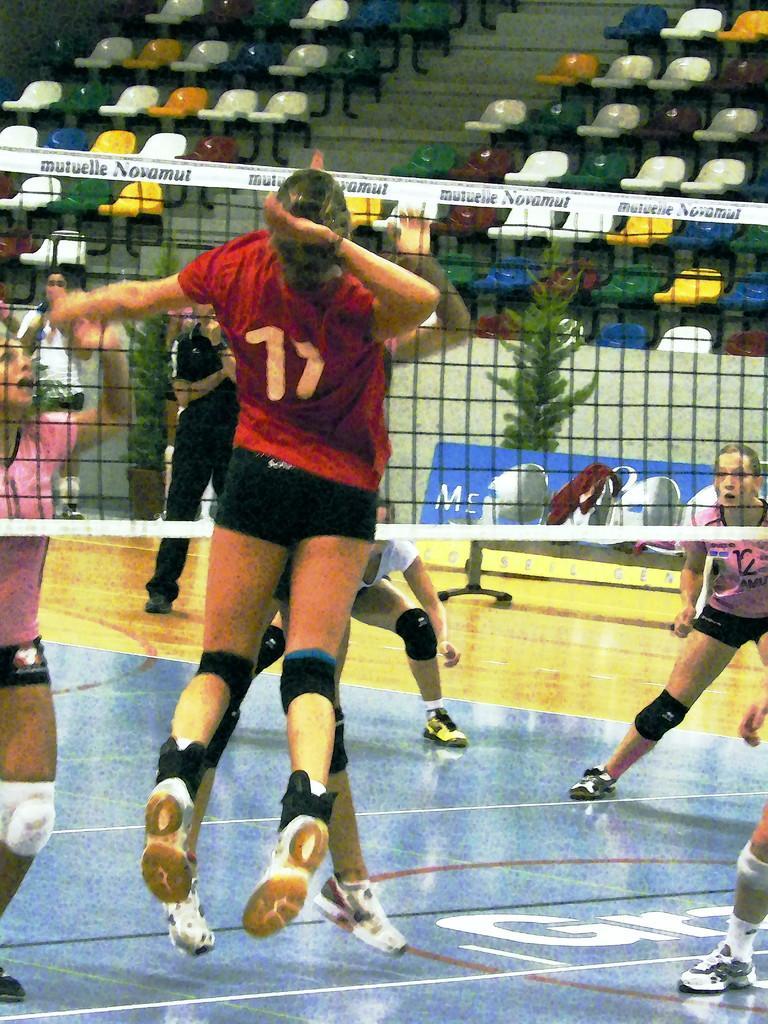Can you describe this image briefly? In this picture we can see people on the ground, here we can see a net and in the background we can see plants, chairs. 